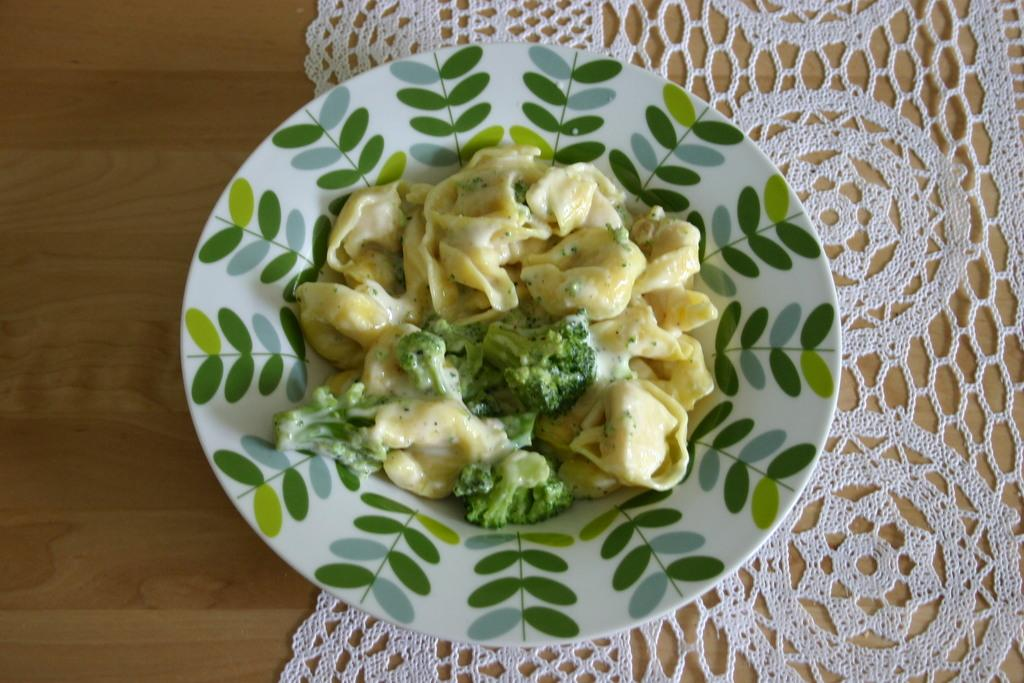What is on the plate that is visible in the image? There is a plate with food items in the image. What specific vegetable can be seen on the plate? There is broccoli on the plate. What other food items are present on the plate? There are other food items on the plate. What is covering the table in the image? There is a cloth on the table in the image. How does the broccoli expand in the image? The broccoli does not expand in the image; it is a static image and the broccoli remains the same size. 